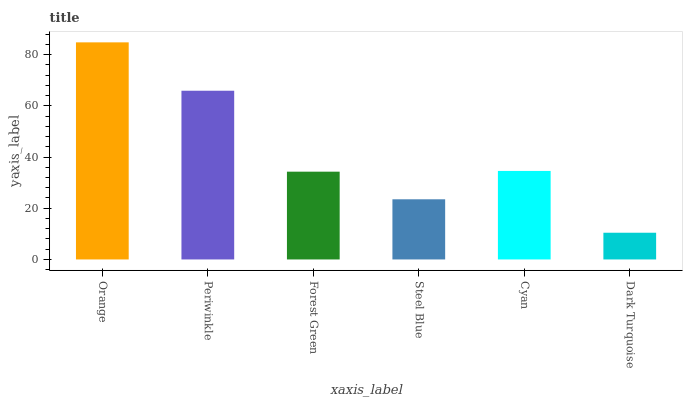Is Dark Turquoise the minimum?
Answer yes or no. Yes. Is Orange the maximum?
Answer yes or no. Yes. Is Periwinkle the minimum?
Answer yes or no. No. Is Periwinkle the maximum?
Answer yes or no. No. Is Orange greater than Periwinkle?
Answer yes or no. Yes. Is Periwinkle less than Orange?
Answer yes or no. Yes. Is Periwinkle greater than Orange?
Answer yes or no. No. Is Orange less than Periwinkle?
Answer yes or no. No. Is Cyan the high median?
Answer yes or no. Yes. Is Forest Green the low median?
Answer yes or no. Yes. Is Dark Turquoise the high median?
Answer yes or no. No. Is Steel Blue the low median?
Answer yes or no. No. 